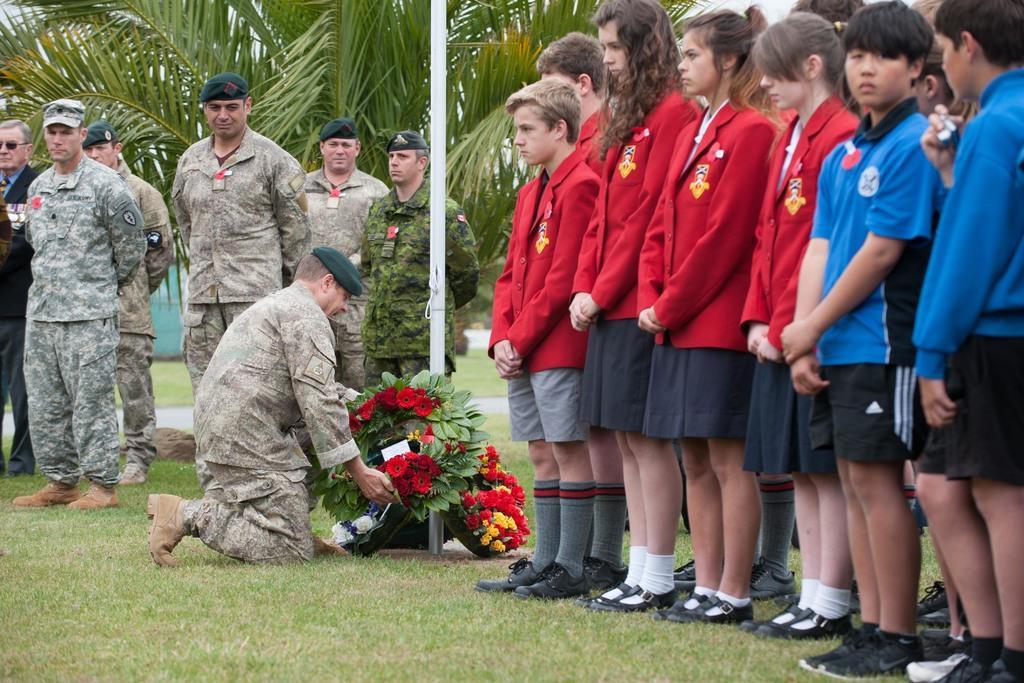Could you give a brief overview of what you see in this image? On the right there are boys and girls standing in uniforms. In the foreground there is grass. In the center of the picture there are bouquet, soldier and a pole. In the center of the background there are soldiers standing and there are tree, plants, grass and other objects. 